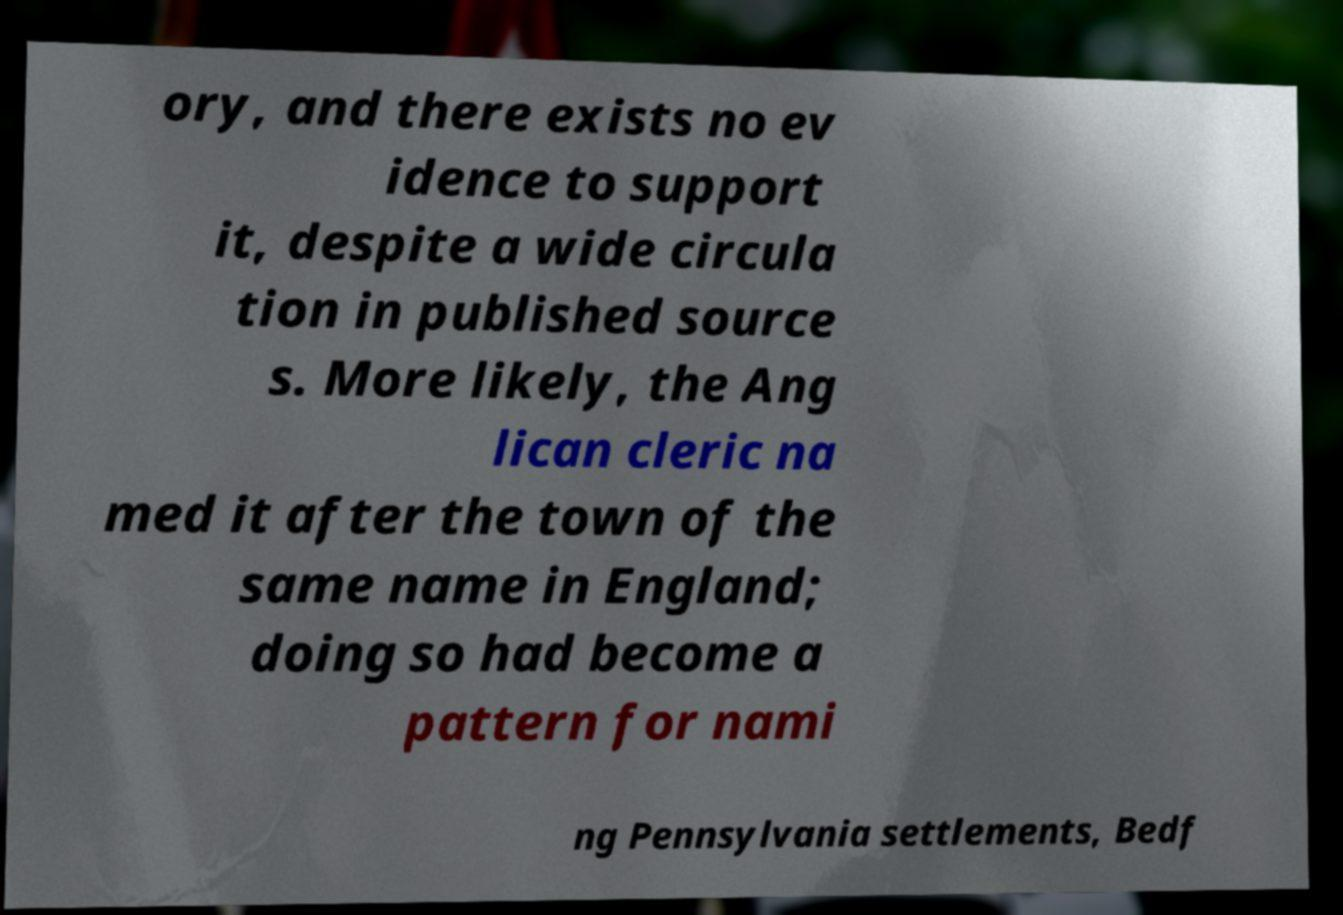Can you read and provide the text displayed in the image?This photo seems to have some interesting text. Can you extract and type it out for me? ory, and there exists no ev idence to support it, despite a wide circula tion in published source s. More likely, the Ang lican cleric na med it after the town of the same name in England; doing so had become a pattern for nami ng Pennsylvania settlements, Bedf 